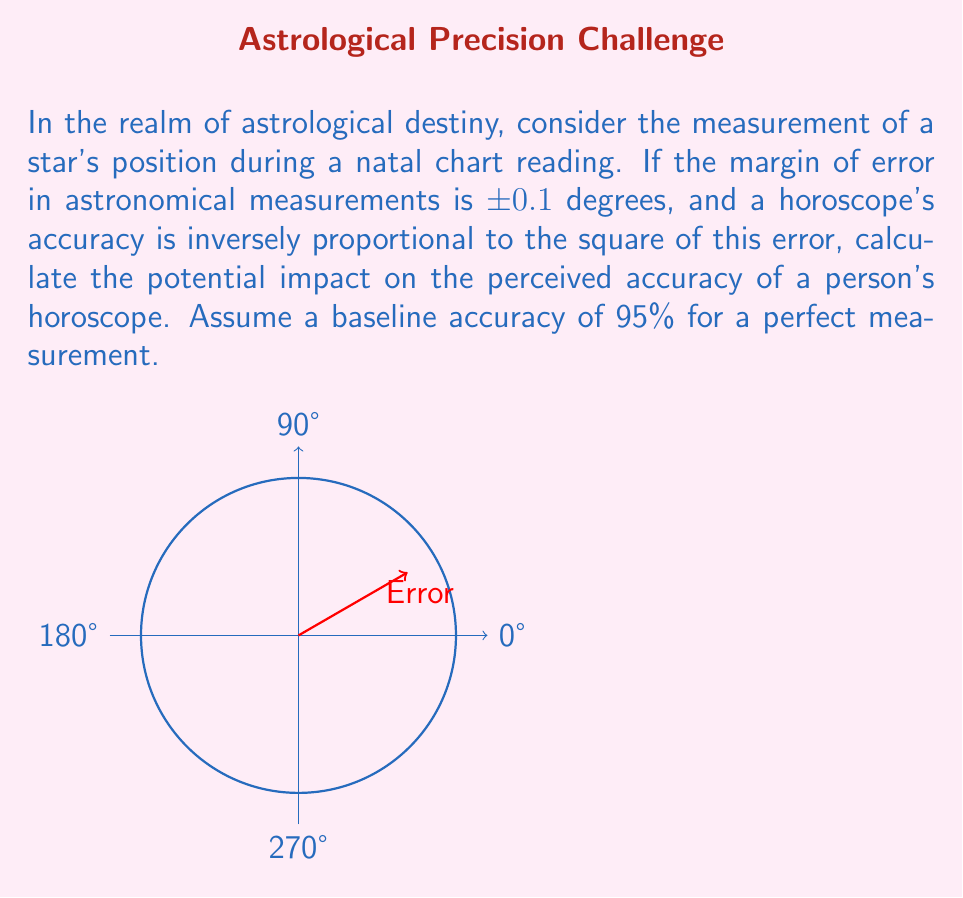Provide a solution to this math problem. Let's approach this step-by-step:

1) First, we need to establish the relationship between the error and the accuracy. Given that the accuracy is inversely proportional to the square of the error, we can express this as:

   $$\text{Accuracy} \propto \frac{1}{\text{Error}^2}$$

2) Let's call the constant of proportionality $k$. For a perfect measurement (error = 0), we have:

   $$95\% = k \cdot \frac{1}{0^2}$$

   However, this is undefined. So instead, let's consider a very small error, say 0.001°:

   $$95\% = k \cdot \frac{1}{0.001^2}$$
   $$k = 95\% \cdot 0.001^2 = 9.5 \times 10^{-7}$$

3) Now, for our actual error of 0.1°, the accuracy would be:

   $$\text{Accuracy} = k \cdot \frac{1}{0.1^2} = 9.5 \times 10^{-7} \cdot 100 = 9.5\%$$

4) The impact on perceived accuracy is the difference between the baseline accuracy and this new accuracy:

   $$\text{Impact} = 95\% - 9.5\% = 85.5\%$$

This significant drop in accuracy highlights the philosophical implications of how small uncertainties in measurements can drastically affect our perception of astrological predictions and, by extension, our understanding of destiny.
Answer: 85.5% reduction in perceived accuracy 